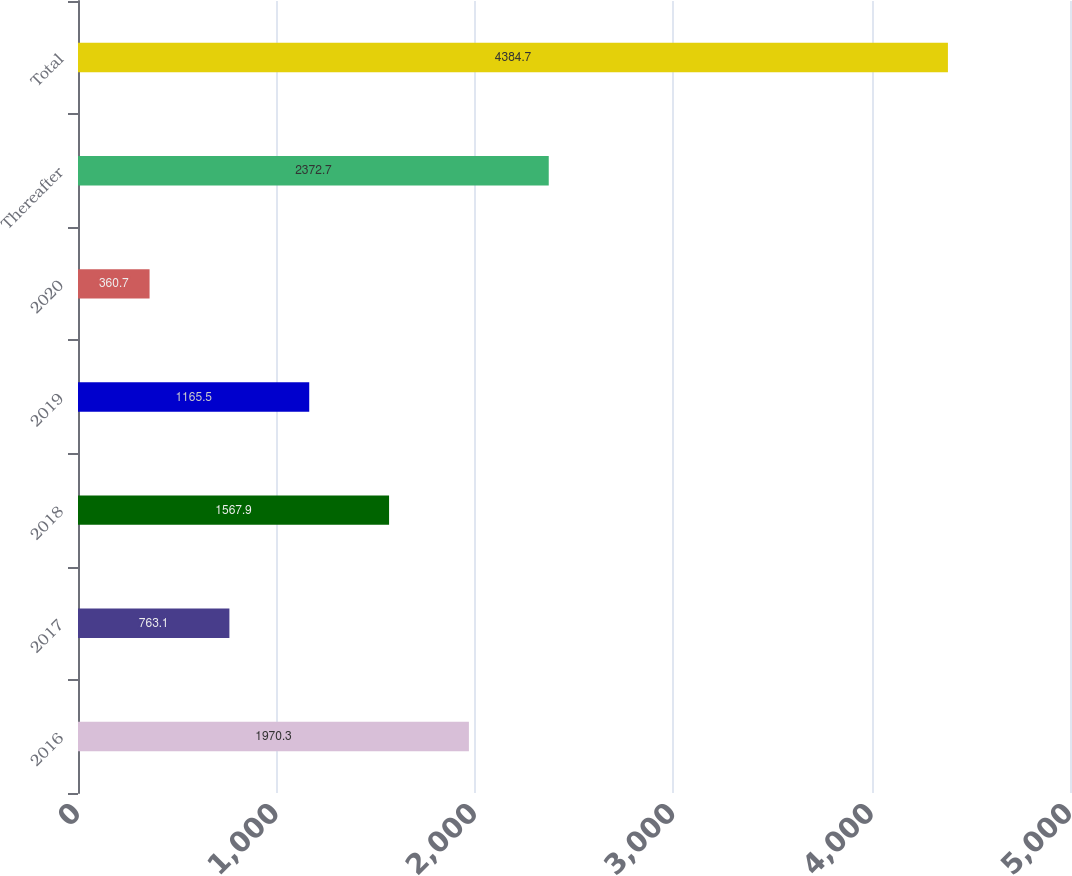<chart> <loc_0><loc_0><loc_500><loc_500><bar_chart><fcel>2016<fcel>2017<fcel>2018<fcel>2019<fcel>2020<fcel>Thereafter<fcel>Total<nl><fcel>1970.3<fcel>763.1<fcel>1567.9<fcel>1165.5<fcel>360.7<fcel>2372.7<fcel>4384.7<nl></chart> 